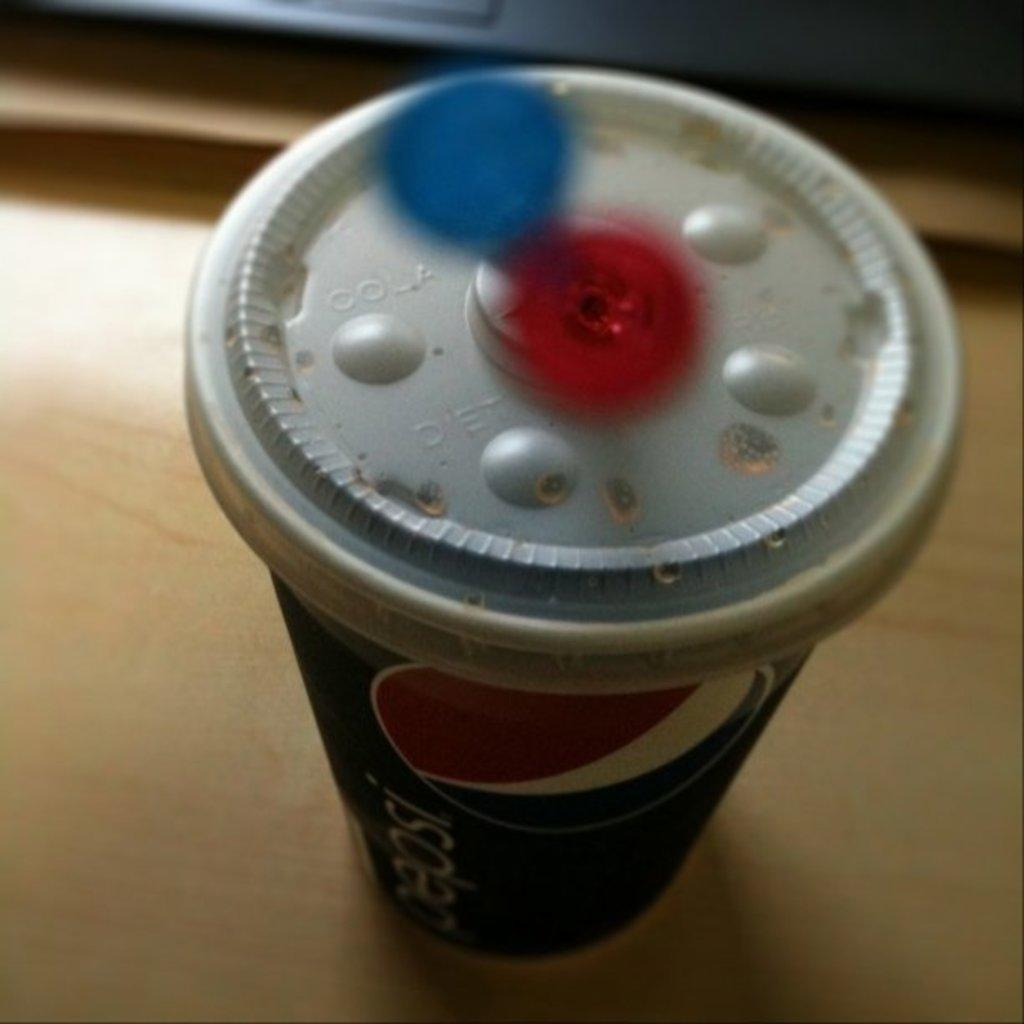<image>
Create a compact narrative representing the image presented. Pepsi soda on top of a wooden table. 